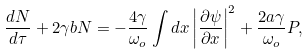<formula> <loc_0><loc_0><loc_500><loc_500>\frac { d { N } } { d \tau } + 2 \gamma b { N } = - \frac { 4 \gamma } { \omega _ { o } } \int d x \left | \frac { \partial \psi } { \partial x } \right | ^ { 2 } + \frac { 2 a \gamma } { \omega _ { o } } { P } ,</formula> 